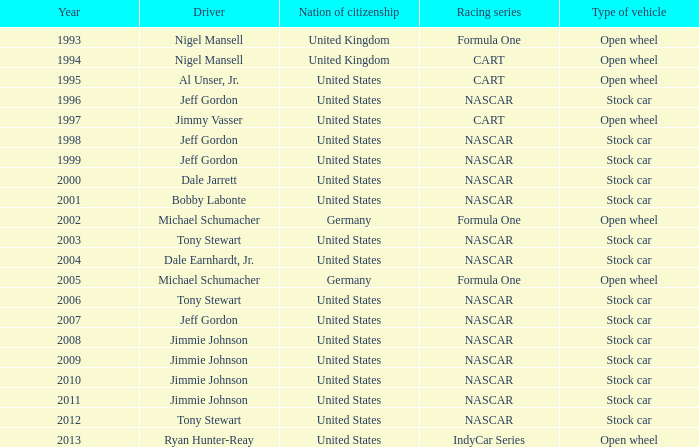What Nation of citizenship has a stock car vehicle with a year of 2012? United States. 